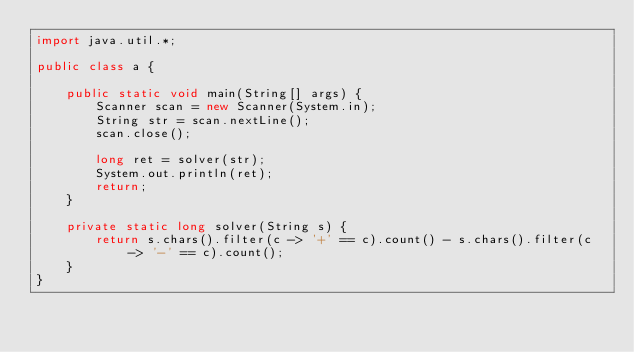Convert code to text. <code><loc_0><loc_0><loc_500><loc_500><_Java_>import java.util.*;

public class a {

    public static void main(String[] args) {
        Scanner scan = new Scanner(System.in);
        String str = scan.nextLine();
        scan.close();

        long ret = solver(str);
        System.out.println(ret);
        return;
    }

    private static long solver(String s) {
        return s.chars().filter(c -> '+' == c).count() - s.chars().filter(c -> '-' == c).count();
    }
}
</code> 